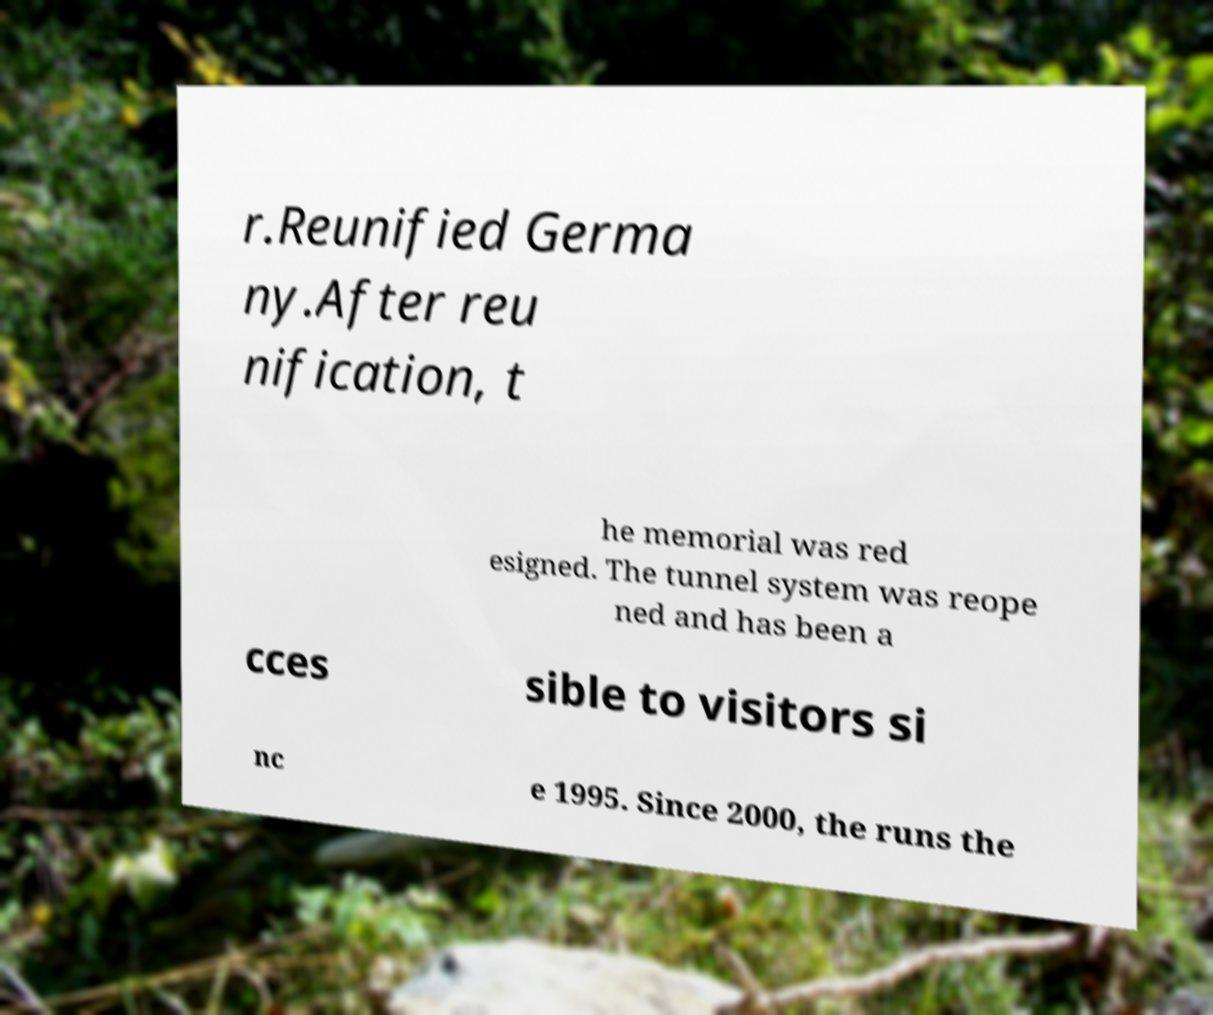Please read and relay the text visible in this image. What does it say? r.Reunified Germa ny.After reu nification, t he memorial was red esigned. The tunnel system was reope ned and has been a cces sible to visitors si nc e 1995. Since 2000, the runs the 